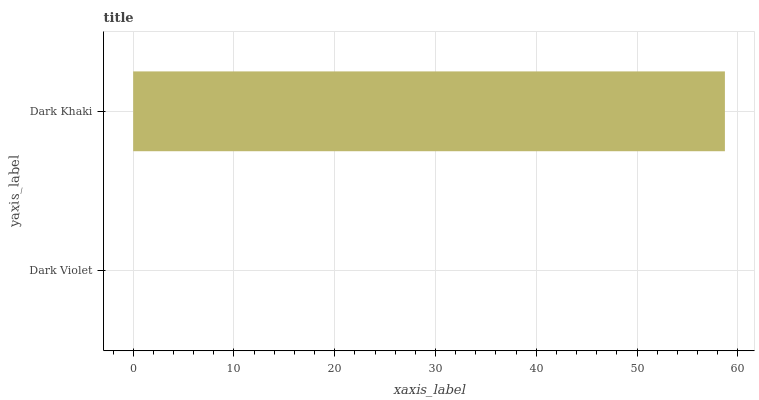Is Dark Violet the minimum?
Answer yes or no. Yes. Is Dark Khaki the maximum?
Answer yes or no. Yes. Is Dark Khaki the minimum?
Answer yes or no. No. Is Dark Khaki greater than Dark Violet?
Answer yes or no. Yes. Is Dark Violet less than Dark Khaki?
Answer yes or no. Yes. Is Dark Violet greater than Dark Khaki?
Answer yes or no. No. Is Dark Khaki less than Dark Violet?
Answer yes or no. No. Is Dark Khaki the high median?
Answer yes or no. Yes. Is Dark Violet the low median?
Answer yes or no. Yes. Is Dark Violet the high median?
Answer yes or no. No. Is Dark Khaki the low median?
Answer yes or no. No. 